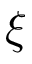Convert formula to latex. <formula><loc_0><loc_0><loc_500><loc_500>\xi</formula> 